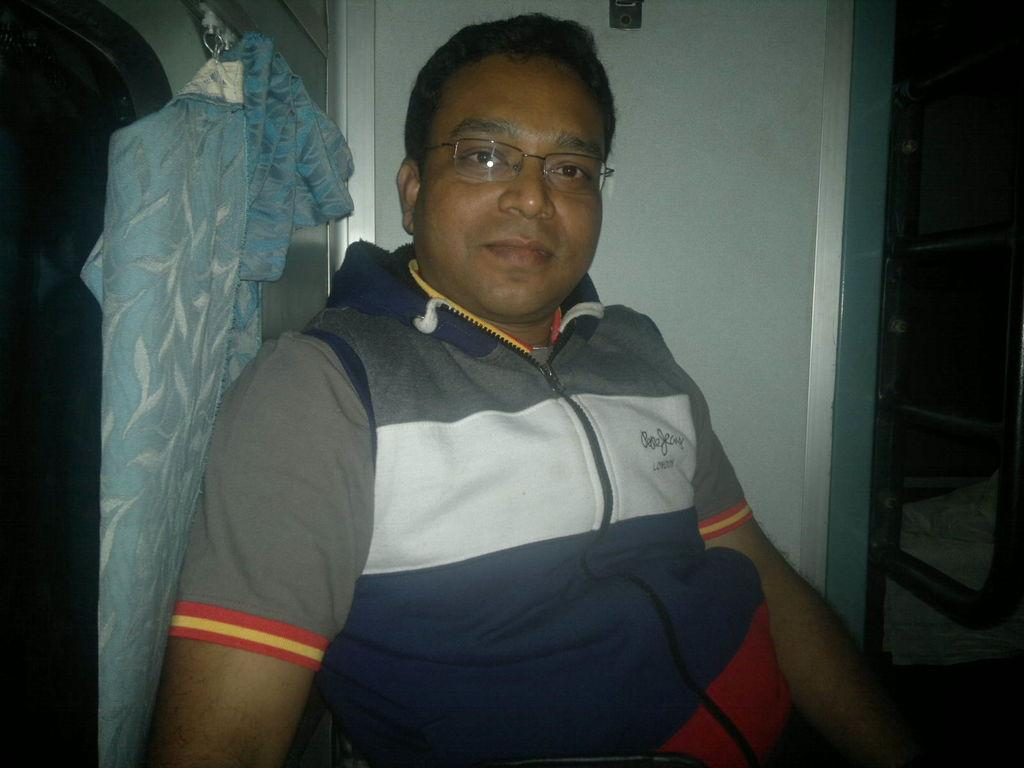What is the main subject of the image? There is a person sitting in the center of the image. What can be seen in the background of the image? There is a wall and a curtain in the background of the image. Are there any objects visible in the background? Yes, there are objects visible in the background of the image. What type of marble is visible on the floor in the image? There is no marble visible on the floor in the image. What color is the chalk used to draw on the wall in the image? There is no chalk or drawing on the wall in the image. 